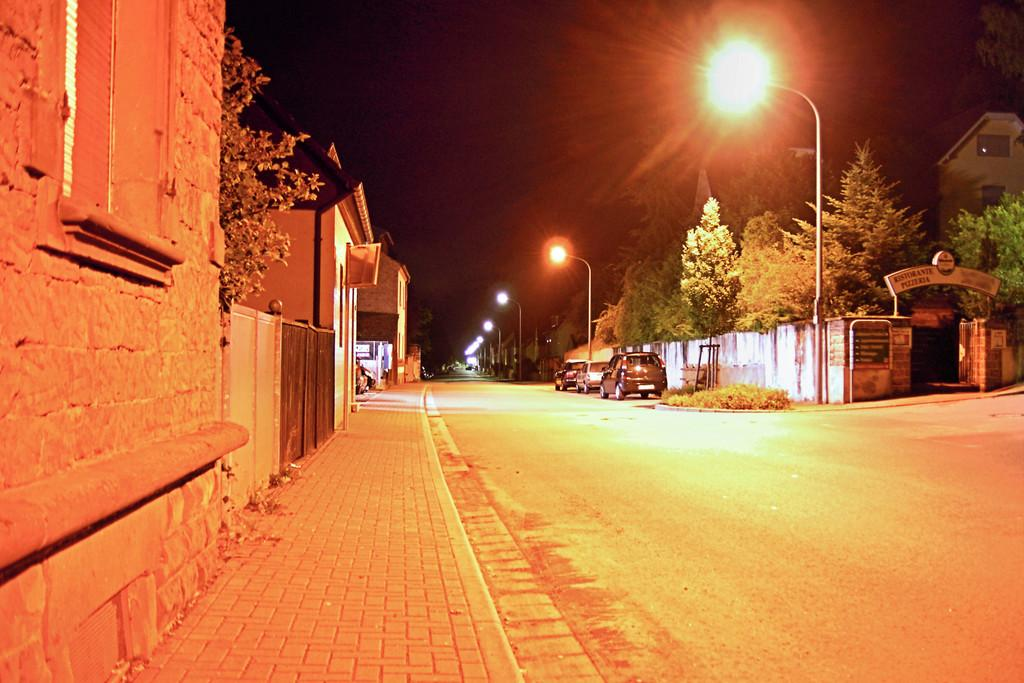What types of man-made structures can be seen in the image? There are vehicles, buildings, and light-poles in the image. What natural elements are present in the image? There are trees in the image. What additional object can be seen in the image? There is a board in the image. What is the color of the sky in the image? The sky appears to be black in color. How many eggs are being held by the friends in the image? There are no friends or eggs present in the image. What type of shock is being experienced by the people in the image? There are no people or shock depicted in the image. 